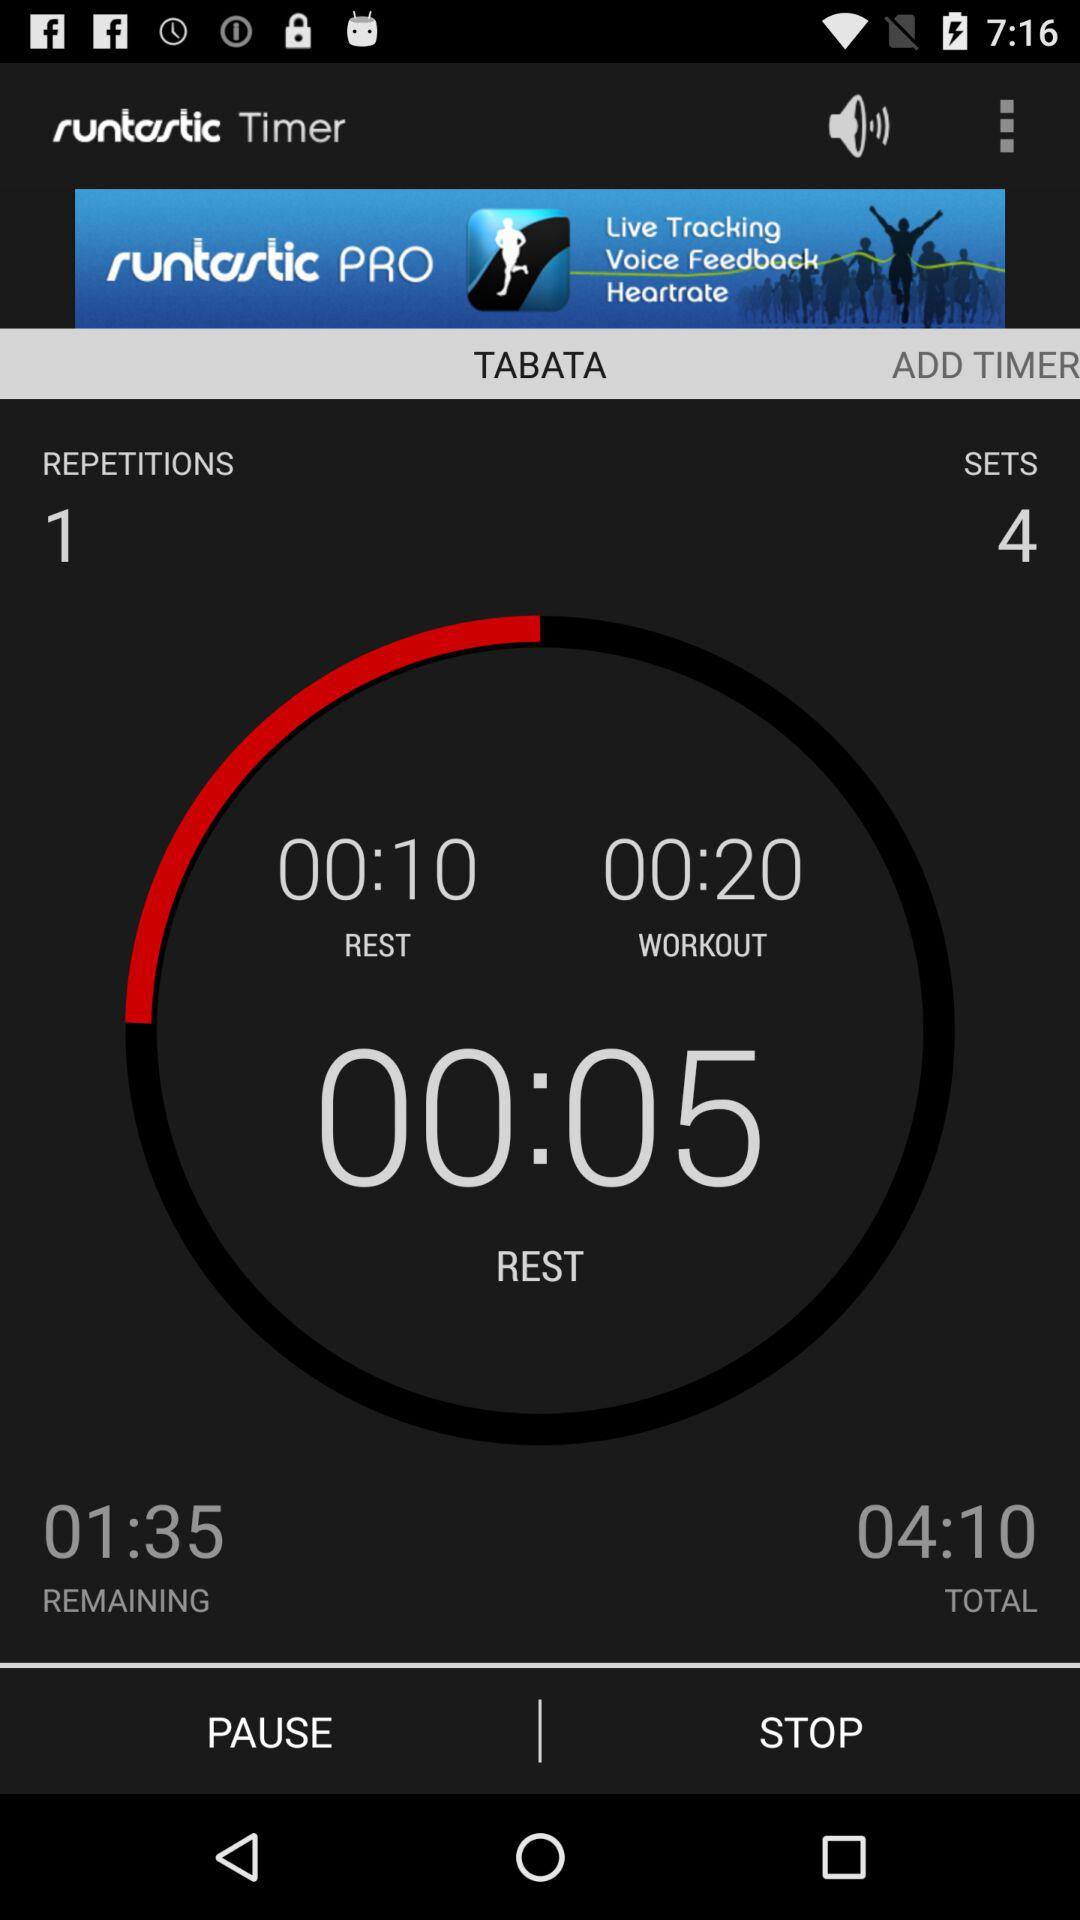What is the duration of the workout? The duration of the workout is 20 seconds. 